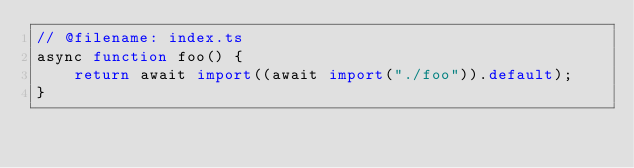<code> <loc_0><loc_0><loc_500><loc_500><_TypeScript_>// @filename: index.ts
async function foo() {
    return await import((await import("./foo")).default);
}</code> 